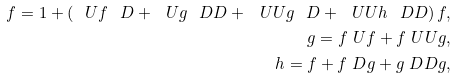<formula> <loc_0><loc_0><loc_500><loc_500>f = 1 + \left ( \ U f \ D + \ U g \ D D + \ U U g \ D + \ U U h \ D D \right ) f , \\ g = f \ U f + f \ U U g , \\ h = f + f \ D g + g \ D D g ,</formula> 